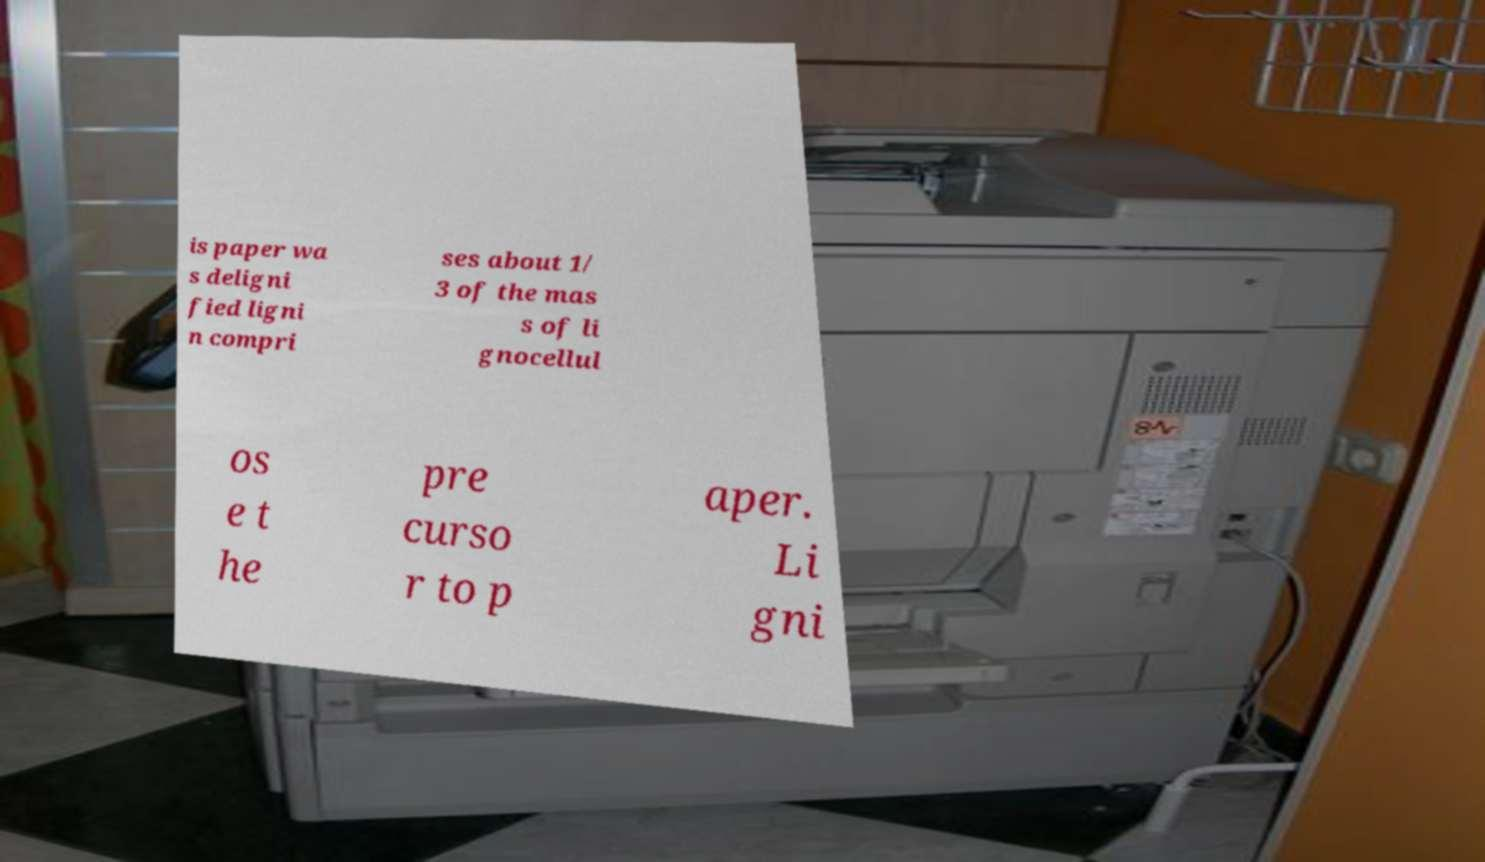Could you assist in decoding the text presented in this image and type it out clearly? is paper wa s deligni fied ligni n compri ses about 1/ 3 of the mas s of li gnocellul os e t he pre curso r to p aper. Li gni 